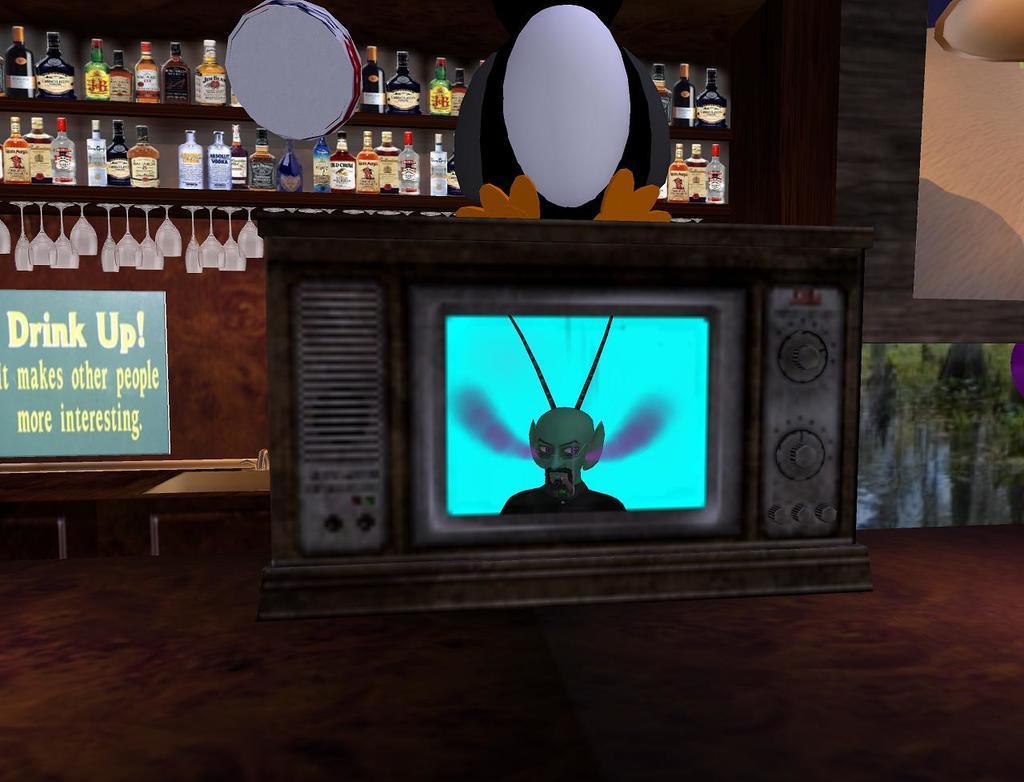Can you describe this image briefly? In this image we can see a television and other objects. In the background of the image there are some bottles, board, wooden objects, wall and other objects. At the bottom of the image there is the floor. 